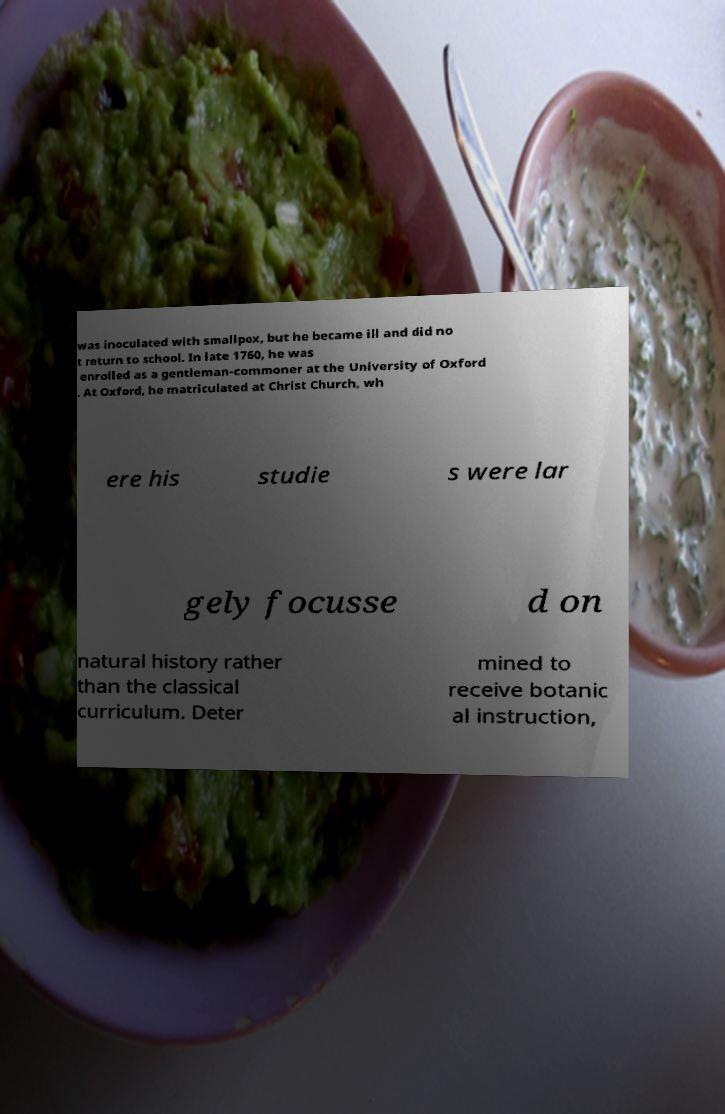Can you read and provide the text displayed in the image?This photo seems to have some interesting text. Can you extract and type it out for me? was inoculated with smallpox, but he became ill and did no t return to school. In late 1760, he was enrolled as a gentleman-commoner at the University of Oxford . At Oxford, he matriculated at Christ Church, wh ere his studie s were lar gely focusse d on natural history rather than the classical curriculum. Deter mined to receive botanic al instruction, 